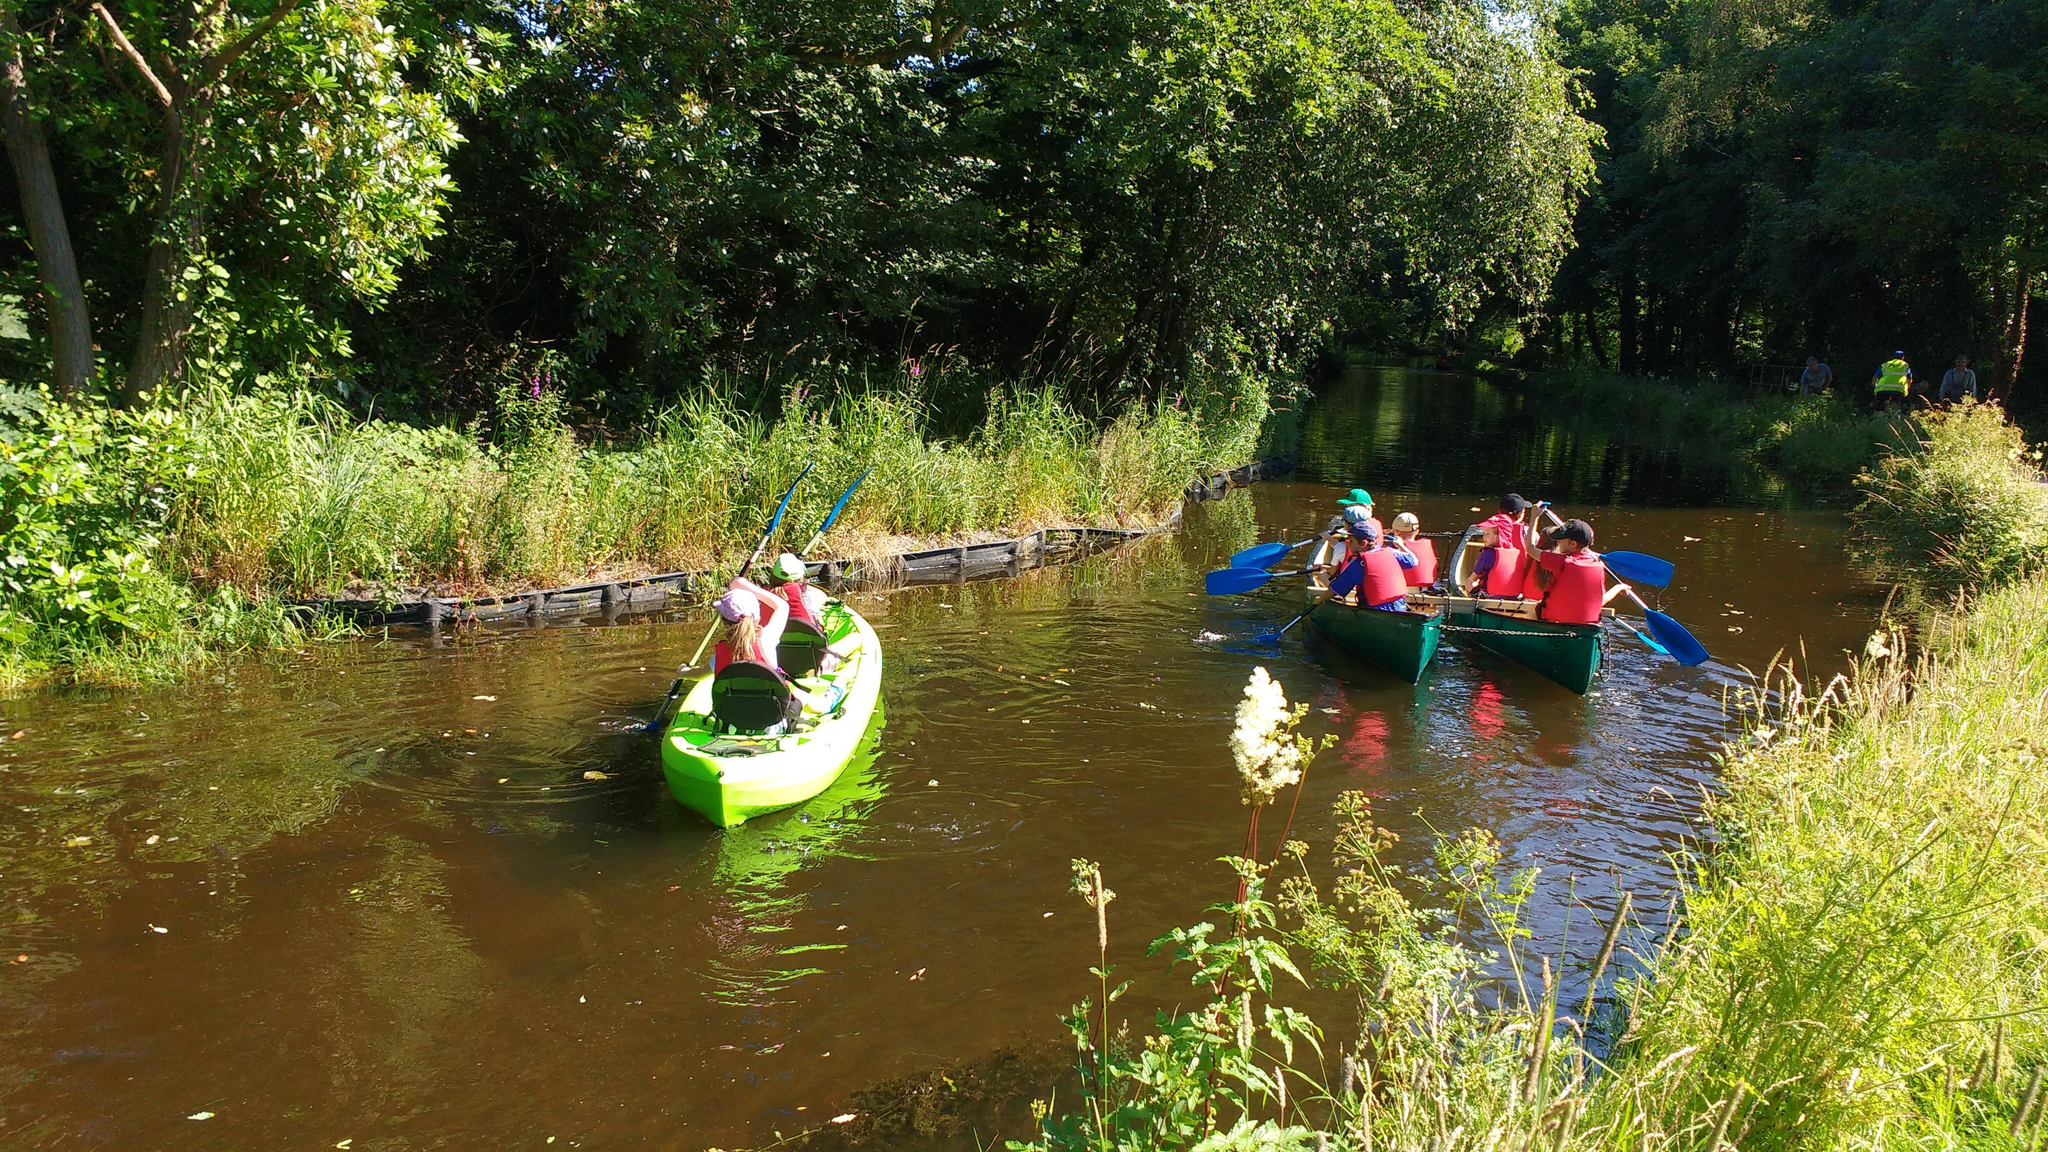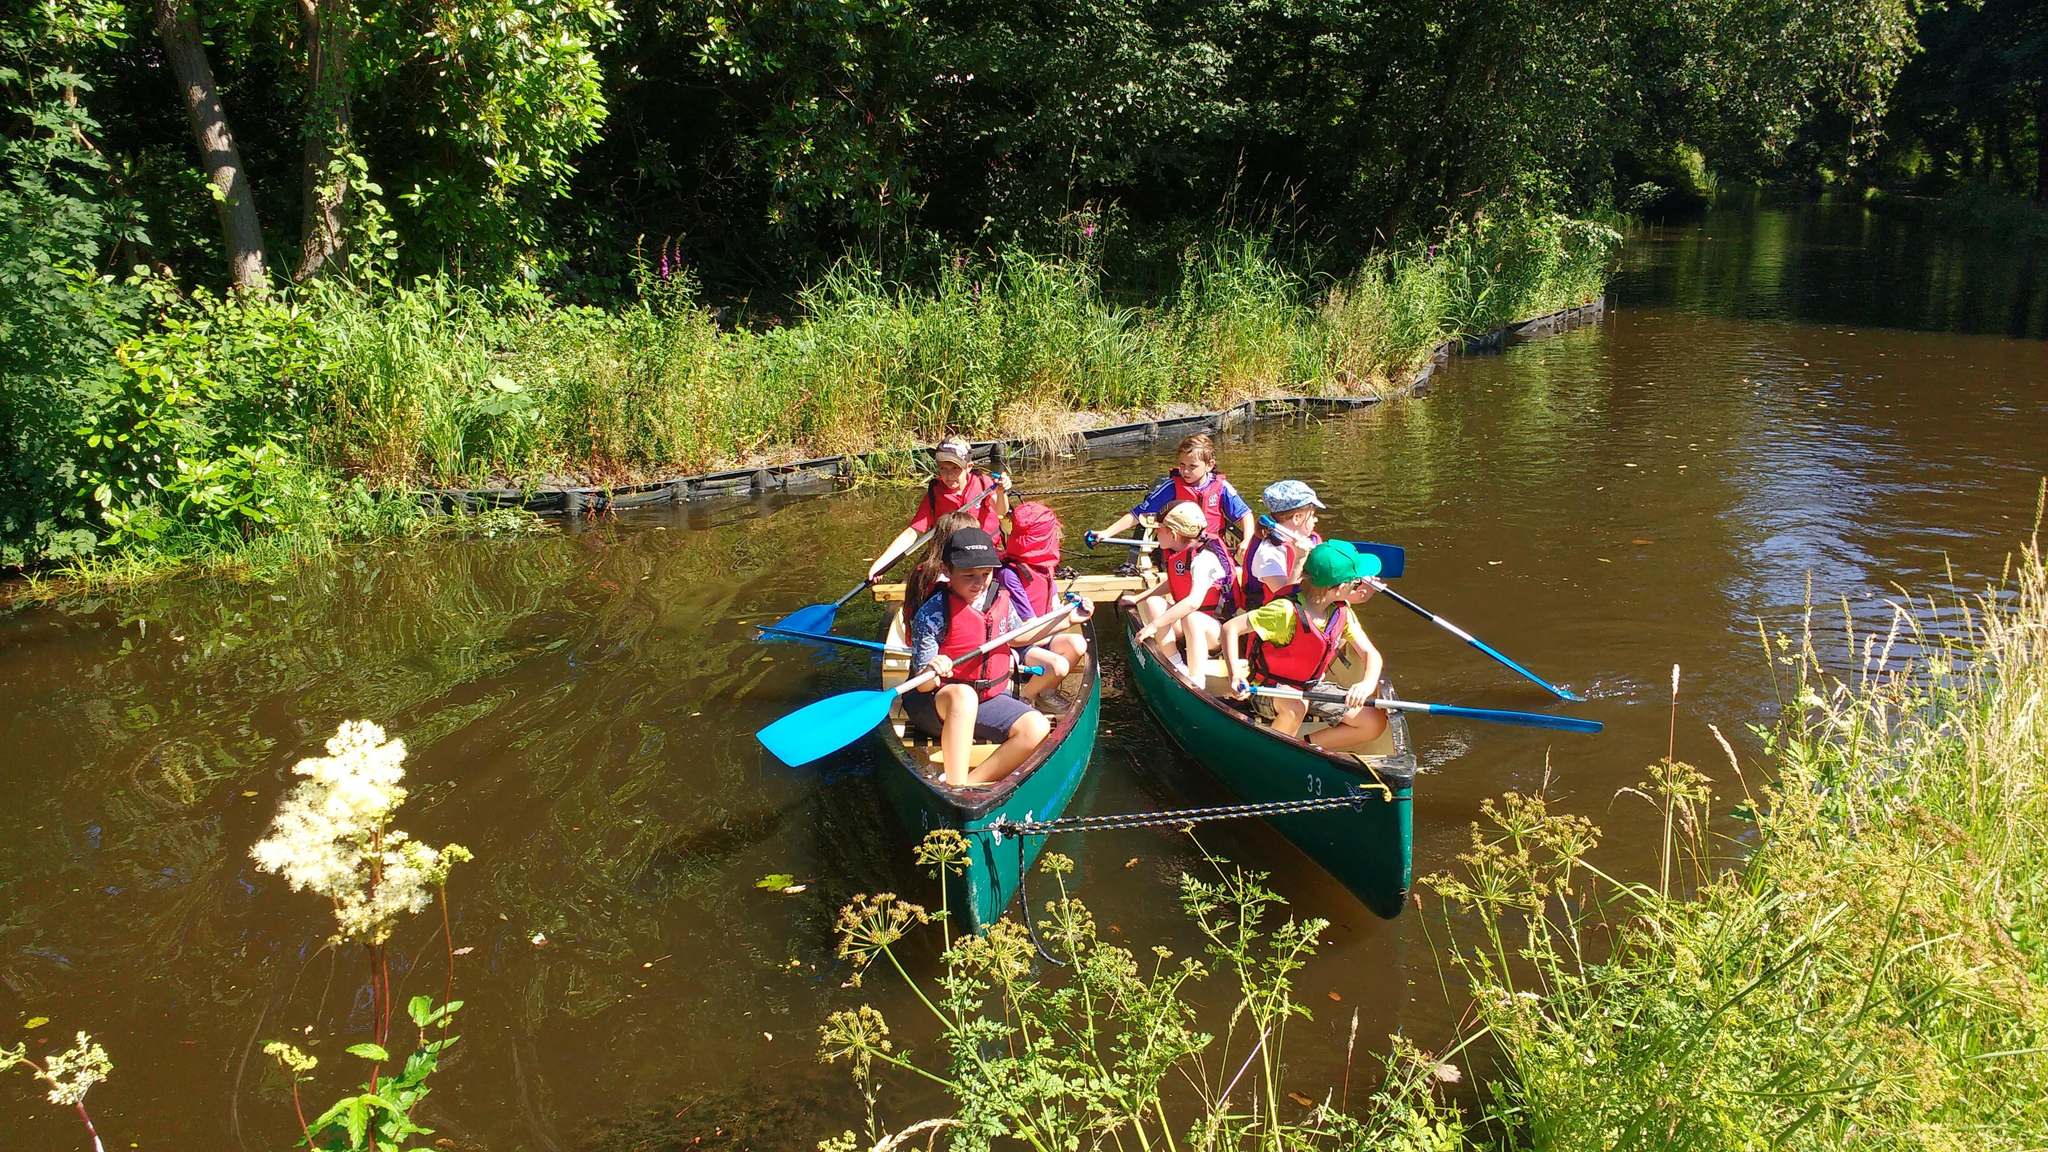The first image is the image on the left, the second image is the image on the right. Examine the images to the left and right. Is the description "An image includes a red canoe with three riders and no other canoe with a seated person in it." accurate? Answer yes or no. No. 